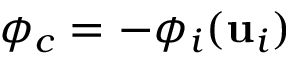<formula> <loc_0><loc_0><loc_500><loc_500>\phi _ { c } = - \phi _ { i } ( u _ { i } )</formula> 